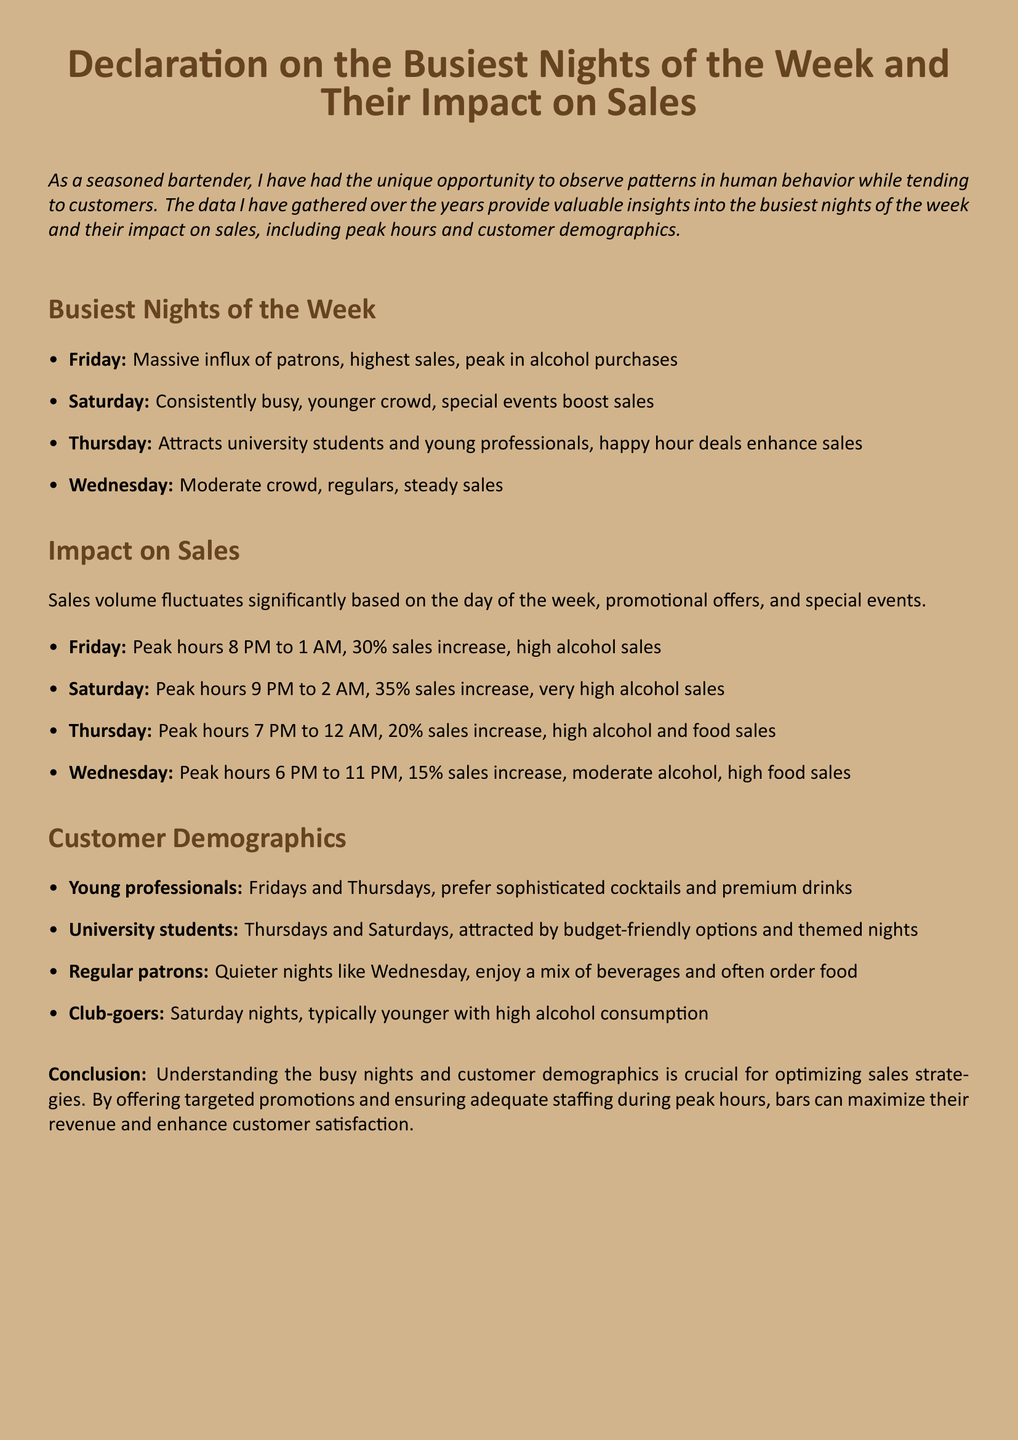What is the busiest night of the week? The busiest night of the week is when there is a massive influx of patrons and highest sales, which is Friday.
Answer: Friday What percentage sales increase occurs on Saturday? The document states that Saturday has a 35% sales increase during peak hours.
Answer: 35% What time does peak hour start on Thursday? According to the information, peak hours on Thursday start at 7 PM.
Answer: 7 PM Who mainly frequent the bar on Wednesday nights? The document mentions that regular patrons typically enjoy quieter nights like Wednesday.
Answer: Regular patrons What type of drinks do young professionals prefer? Young professionals are noted to prefer sophisticated cocktails and premium drinks on Fridays and Thursdays.
Answer: Sophisticated cocktails What is the peak hour duration for Fridays? The peak hour duration for Fridays is from 8 PM to 1 AM.
Answer: 8 PM to 1 AM Which demographic is attracted by budget-friendly options? The document indicates that university students are attracted by budget-friendly options and themed nights.
Answer: University students What is the sales increase percentage on Wednesday? The sales increase on Wednesday is 15%, as mentioned in the document.
Answer: 15% What nights are characterized by high food sales? Thursdays and Wednesdays are characterized by high food sales according to the analysis.
Answer: Thursdays and Wednesdays 